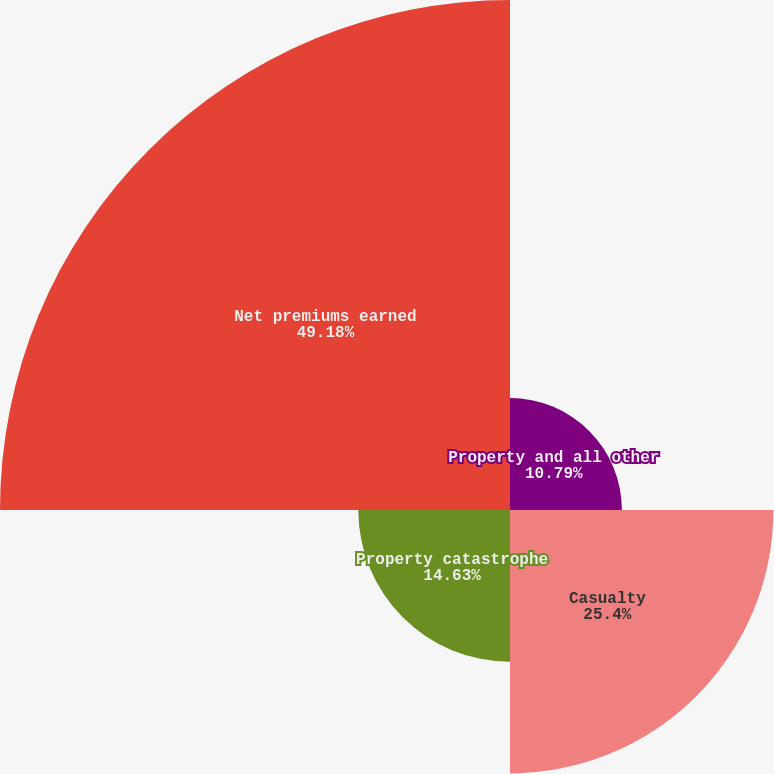<chart> <loc_0><loc_0><loc_500><loc_500><pie_chart><fcel>Property and all other<fcel>Casualty<fcel>Property catastrophe<fcel>Net premiums earned<nl><fcel>10.79%<fcel>25.4%<fcel>14.63%<fcel>49.18%<nl></chart> 